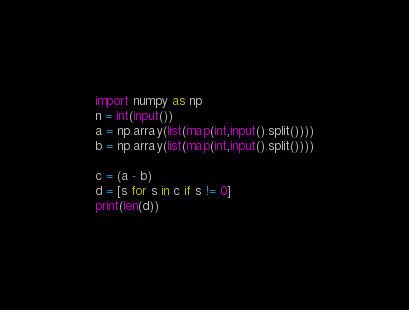<code> <loc_0><loc_0><loc_500><loc_500><_Python_>import numpy as np
n = int(input())
a = np.array(list(map(int,input().split())))
b = np.array(list(map(int,input().split())))

c = (a - b)
d = [s for s in c if s != 0]
print(len(d))</code> 